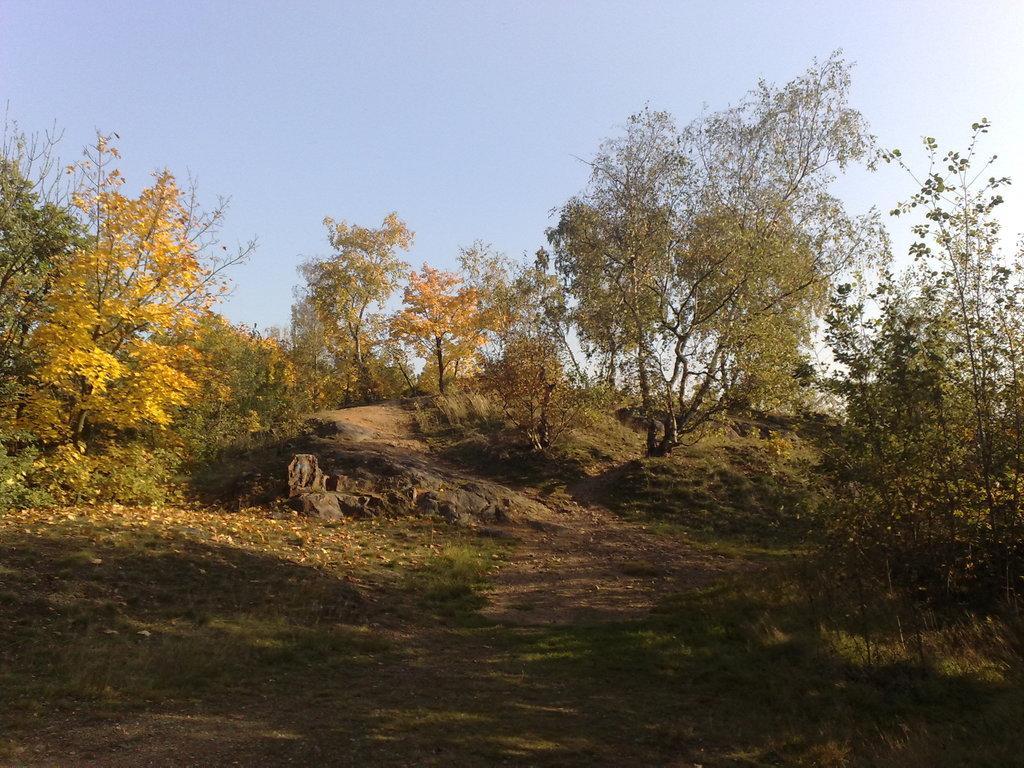In one or two sentences, can you explain what this image depicts? In this image there are rocks, trees. In the background of the image there is sky. At the bottom of the image there is grass on the surface. 